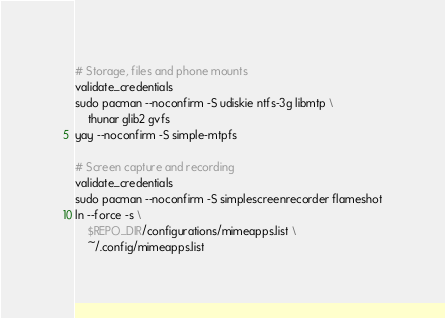Convert code to text. <code><loc_0><loc_0><loc_500><loc_500><_Bash_># Storage, files and phone mounts
validate_credentials
sudo pacman --noconfirm -S udiskie ntfs-3g libmtp \
    thunar glib2 gvfs
yay --noconfirm -S simple-mtpfs

# Screen capture and recording
validate_credentials
sudo pacman --noconfirm -S simplescreenrecorder flameshot
ln --force -s \
    $REPO_DIR/configurations/mimeapps.list \
    ~/.config/mimeapps.list
</code> 